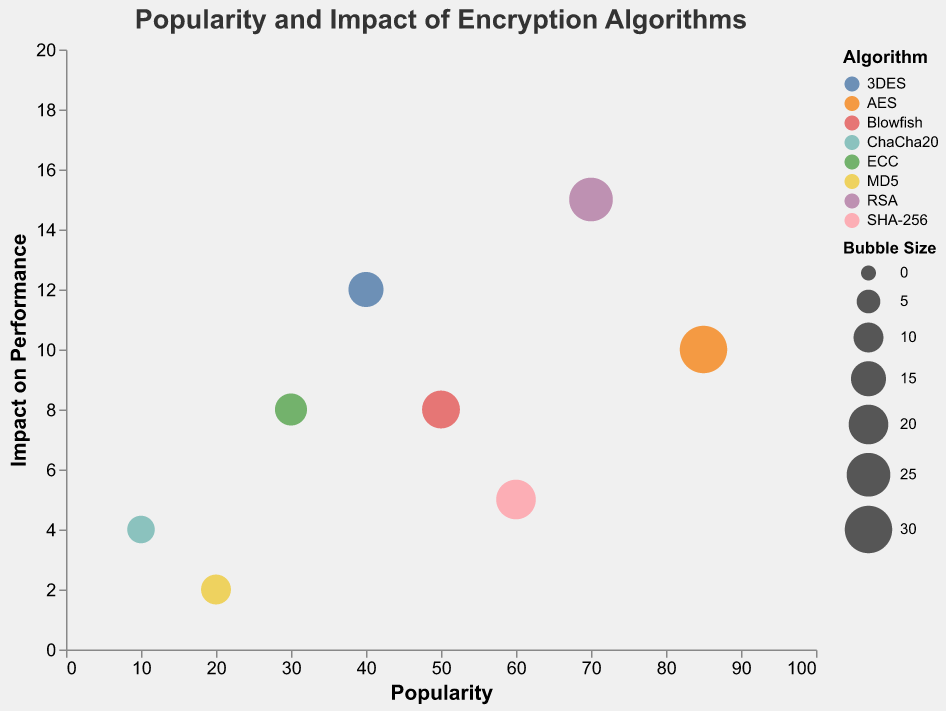What's the title of the figure? The title of the figure is shown at the top in a larger font size. It clearly states the main information being displayed.
Answer: Popularity and Impact of Encryption Algorithms How many encryption algorithms are represented in the figure? The legend on the right-hand side of the figure lists the different algorithms. By counting them, we can determine how many encryption algorithms are represented.
Answer: 8 Which algorithm has the highest popularity score? By looking at the x-axis (Popularity) and identifying the bubble that is farthest to the right, we can find the algorithm with the highest popularity score.
Answer: AES Which algorithm has the lowest impact on performance? By checking the y-axis (Impact on Performance) and finding the bubble closest to the bottom, we can identify the algorithm with the lowest impact on performance.
Answer: MD5 What is the relationship between "AES" and "RSA" in terms of popularity and performance impact? By locating the bubbles for both AES and RSA, we can compare their positions on the x-axis (Popularity) and y-axis (Impact on Performance). AES has a higher popularity score and a lower impact on performance compared to RSA.
Answer: AES is more popular but has a lower performance impact than RSA What is the combined impact on performance of AES, RSA, and Blowfish? Locate the positions of AES, RSA, and Blowfish along the y-axis (Impact on Performance), then add their values: 10 (AES) + 15 (RSA) + 8 (Blowfish).
Answer: 33 Which algorithm has the largest bubble size and what does it signify? By observing the bubble sizes and consulting the legend or tooltip, we can find the largest bubble size, which signifies the importance or weight of the algorithm in terms of some metric.
Answer: AES, Signifying its higher weight Are there any algorithms with the same impact on performance? If so, which ones? By checking the y-axis and finding any bubbles at the same y-axis level, we can determine if there are multiple algorithms with the same impact on performance.
Answer: Blowfish and ECC both have an impact on performance of 8 Which algorithms are less popular than 3DES but have a better performance impact? Locate 3DES on the x-axis (Popularity) with a value of 40, then check the y-axis (Impact on Performance) to identify algorithms with a lower popularity score but better performance impact (lower value on y-axis).
Answer: ChaCha20, MD5 